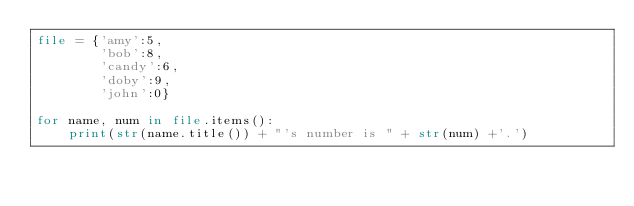Convert code to text. <code><loc_0><loc_0><loc_500><loc_500><_Python_>file = {'amy':5,
        'bob':8,
        'candy':6,
        'doby':9,
        'john':0}

for name, num in file.items():
    print(str(name.title()) + "'s number is " + str(num) +'.')</code> 